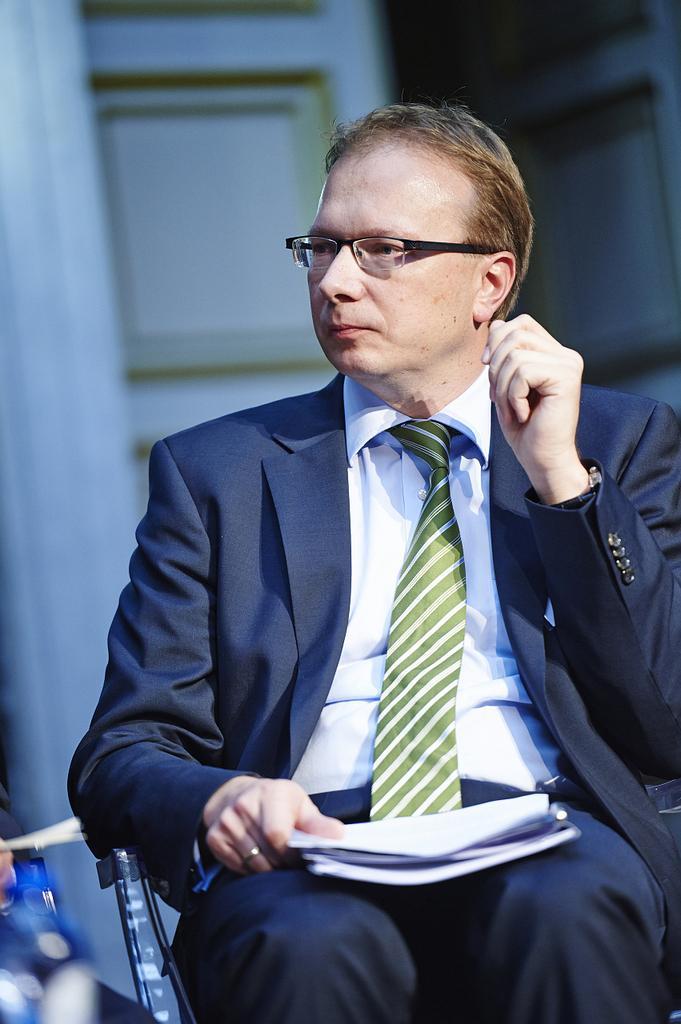Can you describe this image briefly? In the background we can see the door. In this picture we can see a man siting on a chair, wearing spectacles, shirt, tie and a blazer. He is holding papers in his hand. 